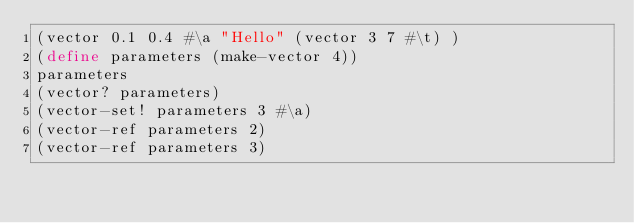<code> <loc_0><loc_0><loc_500><loc_500><_Scheme_>(vector 0.1 0.4 #\a "Hello" (vector 3 7 #\t) )
(define parameters (make-vector 4))
parameters
(vector? parameters)
(vector-set! parameters 3 #\a)
(vector-ref parameters 2)
(vector-ref parameters 3)
</code> 